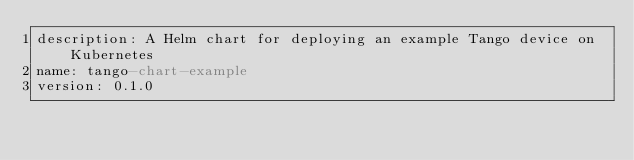Convert code to text. <code><loc_0><loc_0><loc_500><loc_500><_YAML_>description: A Helm chart for deploying an example Tango device on Kubernetes
name: tango-chart-example
version: 0.1.0
</code> 